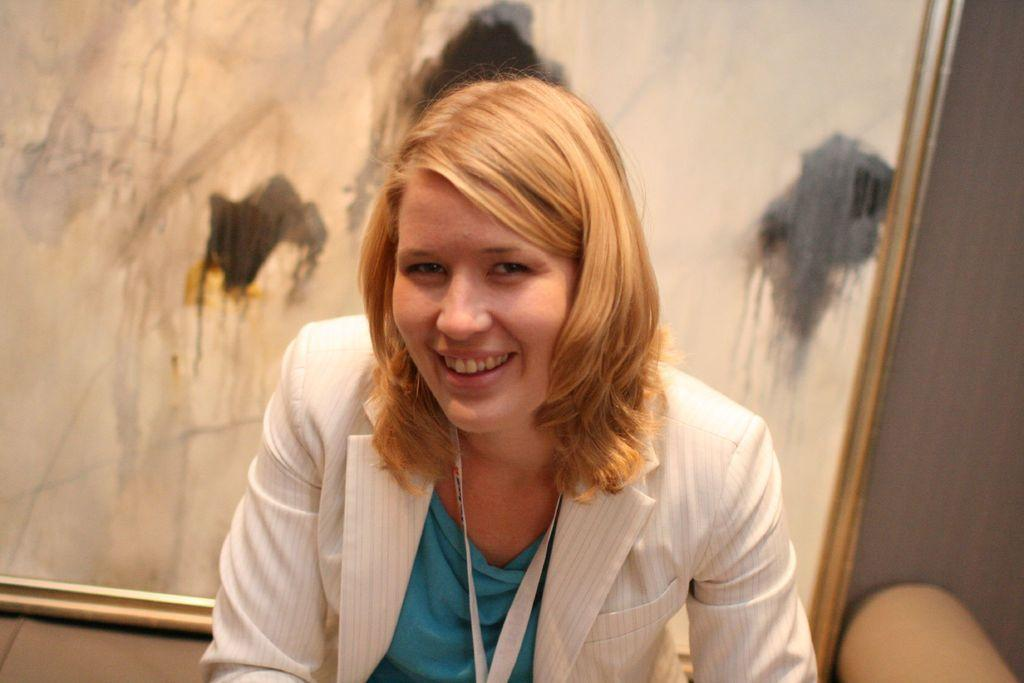Who is present in the image? There is a person in the image. What is the person wearing that provides identification? The person is wearing an ID card. What can be seen beside the person? There is an object beside the person. What is visible in the background of the image? There is a wall and a photo frame in the background of the image. How many snails are crawling on the person's ID card in the image? There are no snails present in the image, so it is not possible to determine how many might be crawling on the ID card. 